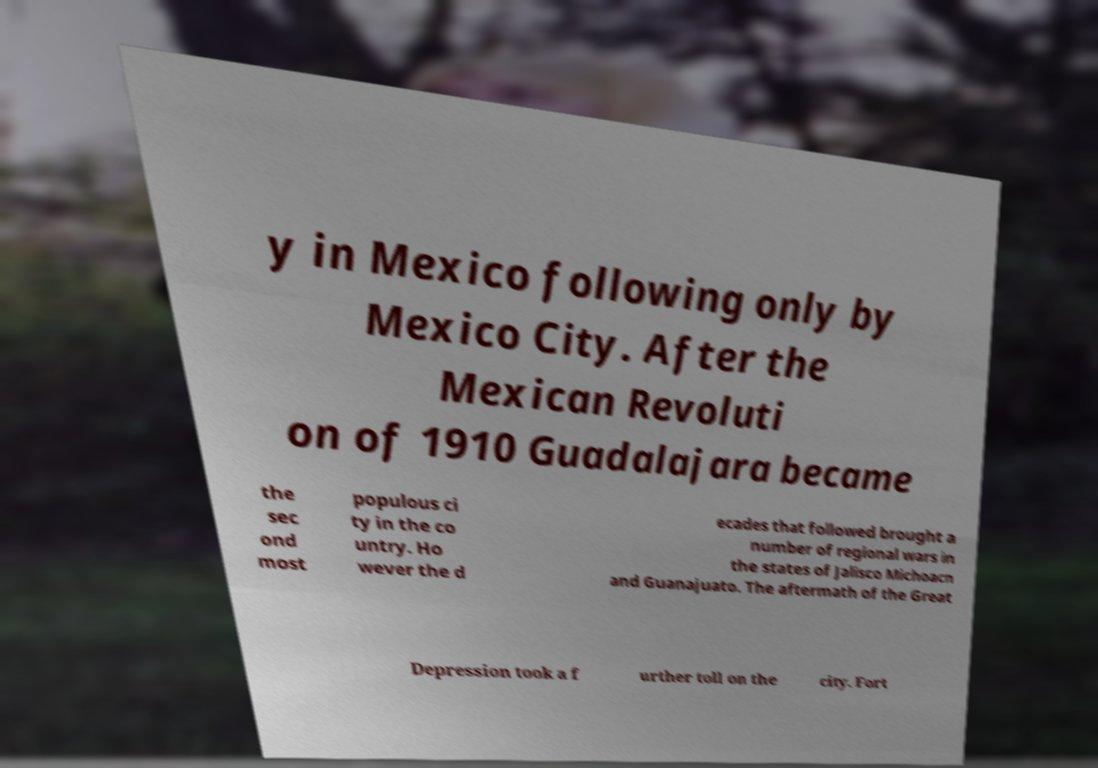There's text embedded in this image that I need extracted. Can you transcribe it verbatim? y in Mexico following only by Mexico City. After the Mexican Revoluti on of 1910 Guadalajara became the sec ond most populous ci ty in the co untry. Ho wever the d ecades that followed brought a number of regional wars in the states of Jalisco Michoacn and Guanajuato. The aftermath of the Great Depression took a f urther toll on the city. Fort 